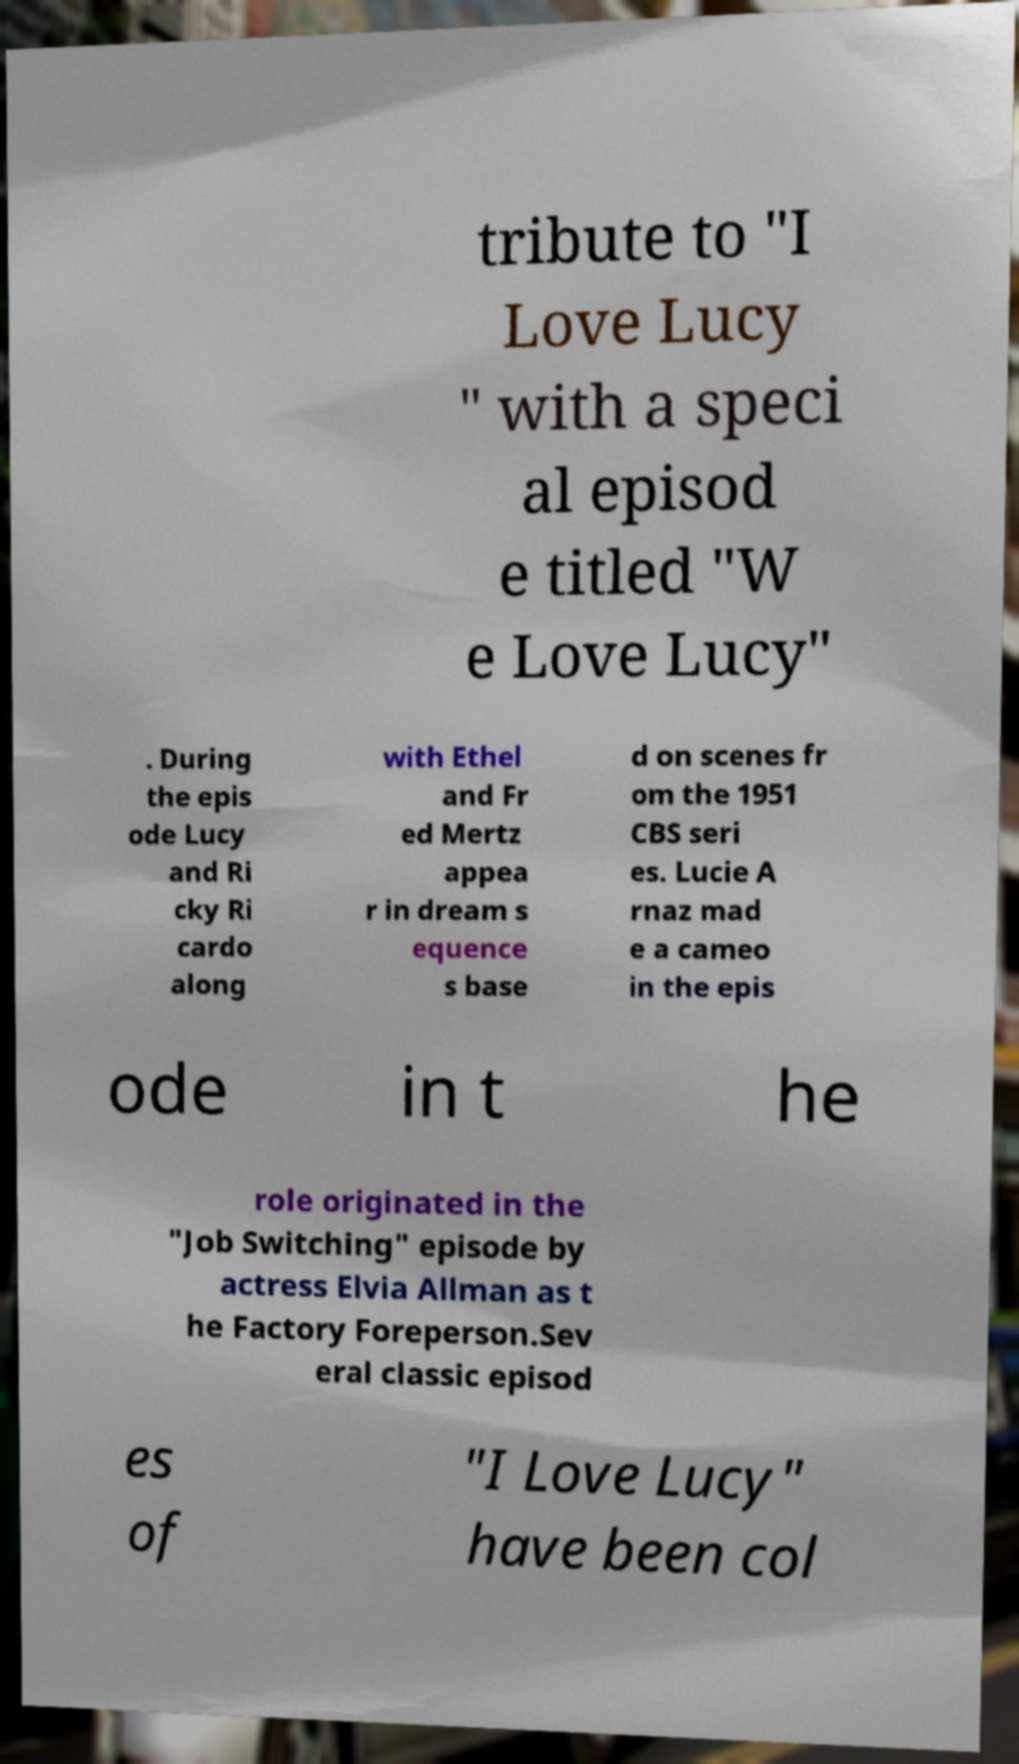For documentation purposes, I need the text within this image transcribed. Could you provide that? tribute to "I Love Lucy " with a speci al episod e titled "W e Love Lucy" . During the epis ode Lucy and Ri cky Ri cardo along with Ethel and Fr ed Mertz appea r in dream s equence s base d on scenes fr om the 1951 CBS seri es. Lucie A rnaz mad e a cameo in the epis ode in t he role originated in the "Job Switching" episode by actress Elvia Allman as t he Factory Foreperson.Sev eral classic episod es of "I Love Lucy" have been col 